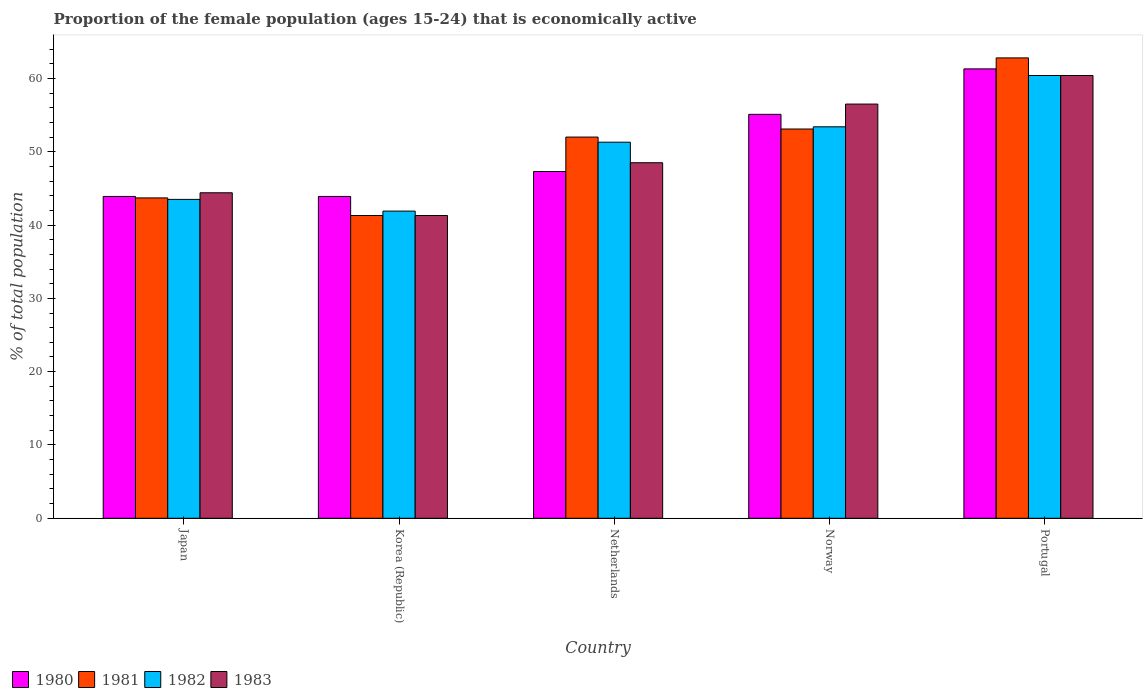How many different coloured bars are there?
Give a very brief answer. 4. How many groups of bars are there?
Give a very brief answer. 5. Are the number of bars on each tick of the X-axis equal?
Keep it short and to the point. Yes. How many bars are there on the 1st tick from the left?
Your response must be concise. 4. How many bars are there on the 4th tick from the right?
Your answer should be compact. 4. What is the label of the 1st group of bars from the left?
Keep it short and to the point. Japan. What is the proportion of the female population that is economically active in 1981 in Norway?
Ensure brevity in your answer.  53.1. Across all countries, what is the maximum proportion of the female population that is economically active in 1981?
Make the answer very short. 62.8. Across all countries, what is the minimum proportion of the female population that is economically active in 1981?
Provide a succinct answer. 41.3. In which country was the proportion of the female population that is economically active in 1980 maximum?
Provide a succinct answer. Portugal. What is the total proportion of the female population that is economically active in 1980 in the graph?
Provide a succinct answer. 251.5. What is the difference between the proportion of the female population that is economically active in 1980 in Japan and that in Norway?
Offer a very short reply. -11.2. What is the difference between the proportion of the female population that is economically active in 1980 in Portugal and the proportion of the female population that is economically active in 1981 in Netherlands?
Give a very brief answer. 9.3. What is the average proportion of the female population that is economically active in 1980 per country?
Give a very brief answer. 50.3. What is the difference between the proportion of the female population that is economically active of/in 1981 and proportion of the female population that is economically active of/in 1980 in Japan?
Offer a very short reply. -0.2. In how many countries, is the proportion of the female population that is economically active in 1981 greater than 42 %?
Your answer should be compact. 4. What is the ratio of the proportion of the female population that is economically active in 1980 in Japan to that in Norway?
Offer a terse response. 0.8. What is the difference between the highest and the lowest proportion of the female population that is economically active in 1983?
Make the answer very short. 19.1. In how many countries, is the proportion of the female population that is economically active in 1980 greater than the average proportion of the female population that is economically active in 1980 taken over all countries?
Offer a very short reply. 2. Is the sum of the proportion of the female population that is economically active in 1981 in Japan and Netherlands greater than the maximum proportion of the female population that is economically active in 1983 across all countries?
Offer a terse response. Yes. Is it the case that in every country, the sum of the proportion of the female population that is economically active in 1980 and proportion of the female population that is economically active in 1983 is greater than the sum of proportion of the female population that is economically active in 1982 and proportion of the female population that is economically active in 1981?
Provide a succinct answer. No. How many countries are there in the graph?
Ensure brevity in your answer.  5. What is the difference between two consecutive major ticks on the Y-axis?
Ensure brevity in your answer.  10. Where does the legend appear in the graph?
Provide a short and direct response. Bottom left. How many legend labels are there?
Ensure brevity in your answer.  4. How are the legend labels stacked?
Keep it short and to the point. Horizontal. What is the title of the graph?
Provide a short and direct response. Proportion of the female population (ages 15-24) that is economically active. What is the label or title of the X-axis?
Keep it short and to the point. Country. What is the label or title of the Y-axis?
Make the answer very short. % of total population. What is the % of total population of 1980 in Japan?
Provide a short and direct response. 43.9. What is the % of total population of 1981 in Japan?
Your response must be concise. 43.7. What is the % of total population of 1982 in Japan?
Your response must be concise. 43.5. What is the % of total population of 1983 in Japan?
Your answer should be compact. 44.4. What is the % of total population in 1980 in Korea (Republic)?
Your response must be concise. 43.9. What is the % of total population of 1981 in Korea (Republic)?
Your answer should be very brief. 41.3. What is the % of total population in 1982 in Korea (Republic)?
Ensure brevity in your answer.  41.9. What is the % of total population of 1983 in Korea (Republic)?
Your response must be concise. 41.3. What is the % of total population of 1980 in Netherlands?
Offer a terse response. 47.3. What is the % of total population of 1982 in Netherlands?
Your response must be concise. 51.3. What is the % of total population in 1983 in Netherlands?
Your response must be concise. 48.5. What is the % of total population of 1980 in Norway?
Make the answer very short. 55.1. What is the % of total population in 1981 in Norway?
Your answer should be compact. 53.1. What is the % of total population in 1982 in Norway?
Ensure brevity in your answer.  53.4. What is the % of total population of 1983 in Norway?
Keep it short and to the point. 56.5. What is the % of total population of 1980 in Portugal?
Offer a very short reply. 61.3. What is the % of total population of 1981 in Portugal?
Make the answer very short. 62.8. What is the % of total population in 1982 in Portugal?
Provide a succinct answer. 60.4. What is the % of total population in 1983 in Portugal?
Offer a very short reply. 60.4. Across all countries, what is the maximum % of total population of 1980?
Your answer should be very brief. 61.3. Across all countries, what is the maximum % of total population in 1981?
Give a very brief answer. 62.8. Across all countries, what is the maximum % of total population of 1982?
Give a very brief answer. 60.4. Across all countries, what is the maximum % of total population in 1983?
Give a very brief answer. 60.4. Across all countries, what is the minimum % of total population of 1980?
Provide a succinct answer. 43.9. Across all countries, what is the minimum % of total population in 1981?
Provide a succinct answer. 41.3. Across all countries, what is the minimum % of total population in 1982?
Your response must be concise. 41.9. Across all countries, what is the minimum % of total population in 1983?
Offer a terse response. 41.3. What is the total % of total population of 1980 in the graph?
Your answer should be compact. 251.5. What is the total % of total population of 1981 in the graph?
Keep it short and to the point. 252.9. What is the total % of total population of 1982 in the graph?
Provide a succinct answer. 250.5. What is the total % of total population of 1983 in the graph?
Your response must be concise. 251.1. What is the difference between the % of total population of 1981 in Japan and that in Korea (Republic)?
Ensure brevity in your answer.  2.4. What is the difference between the % of total population in 1983 in Japan and that in Korea (Republic)?
Make the answer very short. 3.1. What is the difference between the % of total population in 1982 in Japan and that in Netherlands?
Provide a short and direct response. -7.8. What is the difference between the % of total population of 1983 in Japan and that in Netherlands?
Your response must be concise. -4.1. What is the difference between the % of total population of 1980 in Japan and that in Norway?
Offer a very short reply. -11.2. What is the difference between the % of total population in 1980 in Japan and that in Portugal?
Keep it short and to the point. -17.4. What is the difference between the % of total population of 1981 in Japan and that in Portugal?
Your response must be concise. -19.1. What is the difference between the % of total population of 1982 in Japan and that in Portugal?
Offer a very short reply. -16.9. What is the difference between the % of total population in 1981 in Korea (Republic) and that in Netherlands?
Ensure brevity in your answer.  -10.7. What is the difference between the % of total population in 1982 in Korea (Republic) and that in Netherlands?
Give a very brief answer. -9.4. What is the difference between the % of total population in 1982 in Korea (Republic) and that in Norway?
Make the answer very short. -11.5. What is the difference between the % of total population of 1983 in Korea (Republic) and that in Norway?
Offer a terse response. -15.2. What is the difference between the % of total population of 1980 in Korea (Republic) and that in Portugal?
Your answer should be very brief. -17.4. What is the difference between the % of total population of 1981 in Korea (Republic) and that in Portugal?
Provide a succinct answer. -21.5. What is the difference between the % of total population of 1982 in Korea (Republic) and that in Portugal?
Ensure brevity in your answer.  -18.5. What is the difference between the % of total population in 1983 in Korea (Republic) and that in Portugal?
Your answer should be very brief. -19.1. What is the difference between the % of total population in 1980 in Netherlands and that in Norway?
Ensure brevity in your answer.  -7.8. What is the difference between the % of total population of 1981 in Netherlands and that in Norway?
Provide a succinct answer. -1.1. What is the difference between the % of total population in 1982 in Netherlands and that in Norway?
Offer a terse response. -2.1. What is the difference between the % of total population in 1981 in Netherlands and that in Portugal?
Offer a very short reply. -10.8. What is the difference between the % of total population of 1983 in Netherlands and that in Portugal?
Offer a terse response. -11.9. What is the difference between the % of total population of 1980 in Norway and that in Portugal?
Your response must be concise. -6.2. What is the difference between the % of total population of 1981 in Norway and that in Portugal?
Offer a terse response. -9.7. What is the difference between the % of total population in 1982 in Norway and that in Portugal?
Give a very brief answer. -7. What is the difference between the % of total population of 1980 in Japan and the % of total population of 1981 in Korea (Republic)?
Provide a short and direct response. 2.6. What is the difference between the % of total population in 1980 in Japan and the % of total population in 1982 in Korea (Republic)?
Ensure brevity in your answer.  2. What is the difference between the % of total population of 1980 in Japan and the % of total population of 1983 in Korea (Republic)?
Your answer should be compact. 2.6. What is the difference between the % of total population of 1981 in Japan and the % of total population of 1982 in Korea (Republic)?
Offer a terse response. 1.8. What is the difference between the % of total population of 1980 in Japan and the % of total population of 1982 in Netherlands?
Give a very brief answer. -7.4. What is the difference between the % of total population of 1980 in Japan and the % of total population of 1983 in Netherlands?
Make the answer very short. -4.6. What is the difference between the % of total population in 1981 in Japan and the % of total population in 1982 in Netherlands?
Offer a very short reply. -7.6. What is the difference between the % of total population in 1982 in Japan and the % of total population in 1983 in Netherlands?
Offer a terse response. -5. What is the difference between the % of total population of 1980 in Japan and the % of total population of 1983 in Norway?
Make the answer very short. -12.6. What is the difference between the % of total population of 1981 in Japan and the % of total population of 1983 in Norway?
Provide a short and direct response. -12.8. What is the difference between the % of total population of 1982 in Japan and the % of total population of 1983 in Norway?
Make the answer very short. -13. What is the difference between the % of total population in 1980 in Japan and the % of total population in 1981 in Portugal?
Your response must be concise. -18.9. What is the difference between the % of total population in 1980 in Japan and the % of total population in 1982 in Portugal?
Your answer should be very brief. -16.5. What is the difference between the % of total population of 1980 in Japan and the % of total population of 1983 in Portugal?
Your response must be concise. -16.5. What is the difference between the % of total population of 1981 in Japan and the % of total population of 1982 in Portugal?
Your answer should be very brief. -16.7. What is the difference between the % of total population of 1981 in Japan and the % of total population of 1983 in Portugal?
Provide a succinct answer. -16.7. What is the difference between the % of total population of 1982 in Japan and the % of total population of 1983 in Portugal?
Your answer should be very brief. -16.9. What is the difference between the % of total population of 1980 in Korea (Republic) and the % of total population of 1981 in Netherlands?
Your response must be concise. -8.1. What is the difference between the % of total population of 1981 in Korea (Republic) and the % of total population of 1982 in Netherlands?
Provide a short and direct response. -10. What is the difference between the % of total population in 1982 in Korea (Republic) and the % of total population in 1983 in Netherlands?
Keep it short and to the point. -6.6. What is the difference between the % of total population in 1980 in Korea (Republic) and the % of total population in 1981 in Norway?
Provide a succinct answer. -9.2. What is the difference between the % of total population of 1981 in Korea (Republic) and the % of total population of 1982 in Norway?
Offer a terse response. -12.1. What is the difference between the % of total population in 1981 in Korea (Republic) and the % of total population in 1983 in Norway?
Provide a succinct answer. -15.2. What is the difference between the % of total population in 1982 in Korea (Republic) and the % of total population in 1983 in Norway?
Provide a succinct answer. -14.6. What is the difference between the % of total population of 1980 in Korea (Republic) and the % of total population of 1981 in Portugal?
Keep it short and to the point. -18.9. What is the difference between the % of total population in 1980 in Korea (Republic) and the % of total population in 1982 in Portugal?
Offer a terse response. -16.5. What is the difference between the % of total population in 1980 in Korea (Republic) and the % of total population in 1983 in Portugal?
Offer a very short reply. -16.5. What is the difference between the % of total population of 1981 in Korea (Republic) and the % of total population of 1982 in Portugal?
Offer a very short reply. -19.1. What is the difference between the % of total population of 1981 in Korea (Republic) and the % of total population of 1983 in Portugal?
Provide a succinct answer. -19.1. What is the difference between the % of total population of 1982 in Korea (Republic) and the % of total population of 1983 in Portugal?
Make the answer very short. -18.5. What is the difference between the % of total population in 1980 in Netherlands and the % of total population in 1983 in Norway?
Make the answer very short. -9.2. What is the difference between the % of total population of 1980 in Netherlands and the % of total population of 1981 in Portugal?
Give a very brief answer. -15.5. What is the difference between the % of total population of 1980 in Netherlands and the % of total population of 1982 in Portugal?
Your answer should be very brief. -13.1. What is the difference between the % of total population in 1981 in Netherlands and the % of total population in 1982 in Portugal?
Your response must be concise. -8.4. What is the difference between the % of total population in 1982 in Netherlands and the % of total population in 1983 in Portugal?
Ensure brevity in your answer.  -9.1. What is the difference between the % of total population of 1980 in Norway and the % of total population of 1982 in Portugal?
Your answer should be very brief. -5.3. What is the difference between the % of total population of 1980 in Norway and the % of total population of 1983 in Portugal?
Your answer should be compact. -5.3. What is the difference between the % of total population of 1981 in Norway and the % of total population of 1982 in Portugal?
Offer a terse response. -7.3. What is the difference between the % of total population of 1981 in Norway and the % of total population of 1983 in Portugal?
Your answer should be very brief. -7.3. What is the difference between the % of total population of 1982 in Norway and the % of total population of 1983 in Portugal?
Provide a short and direct response. -7. What is the average % of total population in 1980 per country?
Offer a very short reply. 50.3. What is the average % of total population in 1981 per country?
Your answer should be very brief. 50.58. What is the average % of total population of 1982 per country?
Ensure brevity in your answer.  50.1. What is the average % of total population of 1983 per country?
Ensure brevity in your answer.  50.22. What is the difference between the % of total population in 1980 and % of total population in 1981 in Japan?
Offer a terse response. 0.2. What is the difference between the % of total population in 1980 and % of total population in 1982 in Japan?
Offer a terse response. 0.4. What is the difference between the % of total population in 1980 and % of total population in 1981 in Korea (Republic)?
Ensure brevity in your answer.  2.6. What is the difference between the % of total population in 1981 and % of total population in 1982 in Korea (Republic)?
Your answer should be compact. -0.6. What is the difference between the % of total population in 1981 and % of total population in 1983 in Korea (Republic)?
Make the answer very short. 0. What is the difference between the % of total population of 1982 and % of total population of 1983 in Korea (Republic)?
Provide a short and direct response. 0.6. What is the difference between the % of total population in 1980 and % of total population in 1982 in Netherlands?
Ensure brevity in your answer.  -4. What is the difference between the % of total population of 1980 and % of total population of 1983 in Netherlands?
Offer a terse response. -1.2. What is the difference between the % of total population of 1982 and % of total population of 1983 in Netherlands?
Your answer should be very brief. 2.8. What is the difference between the % of total population of 1980 and % of total population of 1981 in Norway?
Keep it short and to the point. 2. What is the difference between the % of total population in 1982 and % of total population in 1983 in Norway?
Offer a terse response. -3.1. What is the difference between the % of total population of 1980 and % of total population of 1981 in Portugal?
Make the answer very short. -1.5. What is the ratio of the % of total population of 1980 in Japan to that in Korea (Republic)?
Your answer should be compact. 1. What is the ratio of the % of total population of 1981 in Japan to that in Korea (Republic)?
Offer a terse response. 1.06. What is the ratio of the % of total population of 1982 in Japan to that in Korea (Republic)?
Your answer should be compact. 1.04. What is the ratio of the % of total population of 1983 in Japan to that in Korea (Republic)?
Make the answer very short. 1.08. What is the ratio of the % of total population of 1980 in Japan to that in Netherlands?
Provide a short and direct response. 0.93. What is the ratio of the % of total population in 1981 in Japan to that in Netherlands?
Make the answer very short. 0.84. What is the ratio of the % of total population of 1982 in Japan to that in Netherlands?
Your answer should be very brief. 0.85. What is the ratio of the % of total population in 1983 in Japan to that in Netherlands?
Offer a terse response. 0.92. What is the ratio of the % of total population of 1980 in Japan to that in Norway?
Offer a very short reply. 0.8. What is the ratio of the % of total population of 1981 in Japan to that in Norway?
Your response must be concise. 0.82. What is the ratio of the % of total population in 1982 in Japan to that in Norway?
Offer a very short reply. 0.81. What is the ratio of the % of total population of 1983 in Japan to that in Norway?
Make the answer very short. 0.79. What is the ratio of the % of total population in 1980 in Japan to that in Portugal?
Your answer should be very brief. 0.72. What is the ratio of the % of total population in 1981 in Japan to that in Portugal?
Give a very brief answer. 0.7. What is the ratio of the % of total population in 1982 in Japan to that in Portugal?
Ensure brevity in your answer.  0.72. What is the ratio of the % of total population of 1983 in Japan to that in Portugal?
Ensure brevity in your answer.  0.74. What is the ratio of the % of total population in 1980 in Korea (Republic) to that in Netherlands?
Offer a terse response. 0.93. What is the ratio of the % of total population in 1981 in Korea (Republic) to that in Netherlands?
Give a very brief answer. 0.79. What is the ratio of the % of total population of 1982 in Korea (Republic) to that in Netherlands?
Offer a terse response. 0.82. What is the ratio of the % of total population in 1983 in Korea (Republic) to that in Netherlands?
Your answer should be very brief. 0.85. What is the ratio of the % of total population of 1980 in Korea (Republic) to that in Norway?
Offer a terse response. 0.8. What is the ratio of the % of total population of 1981 in Korea (Republic) to that in Norway?
Provide a short and direct response. 0.78. What is the ratio of the % of total population in 1982 in Korea (Republic) to that in Norway?
Provide a short and direct response. 0.78. What is the ratio of the % of total population of 1983 in Korea (Republic) to that in Norway?
Make the answer very short. 0.73. What is the ratio of the % of total population of 1980 in Korea (Republic) to that in Portugal?
Keep it short and to the point. 0.72. What is the ratio of the % of total population in 1981 in Korea (Republic) to that in Portugal?
Ensure brevity in your answer.  0.66. What is the ratio of the % of total population in 1982 in Korea (Republic) to that in Portugal?
Offer a very short reply. 0.69. What is the ratio of the % of total population in 1983 in Korea (Republic) to that in Portugal?
Make the answer very short. 0.68. What is the ratio of the % of total population in 1980 in Netherlands to that in Norway?
Give a very brief answer. 0.86. What is the ratio of the % of total population in 1981 in Netherlands to that in Norway?
Your answer should be very brief. 0.98. What is the ratio of the % of total population in 1982 in Netherlands to that in Norway?
Provide a short and direct response. 0.96. What is the ratio of the % of total population in 1983 in Netherlands to that in Norway?
Ensure brevity in your answer.  0.86. What is the ratio of the % of total population in 1980 in Netherlands to that in Portugal?
Your answer should be compact. 0.77. What is the ratio of the % of total population in 1981 in Netherlands to that in Portugal?
Offer a terse response. 0.83. What is the ratio of the % of total population in 1982 in Netherlands to that in Portugal?
Ensure brevity in your answer.  0.85. What is the ratio of the % of total population of 1983 in Netherlands to that in Portugal?
Provide a short and direct response. 0.8. What is the ratio of the % of total population in 1980 in Norway to that in Portugal?
Offer a terse response. 0.9. What is the ratio of the % of total population in 1981 in Norway to that in Portugal?
Your answer should be compact. 0.85. What is the ratio of the % of total population of 1982 in Norway to that in Portugal?
Provide a short and direct response. 0.88. What is the ratio of the % of total population of 1983 in Norway to that in Portugal?
Offer a very short reply. 0.94. What is the difference between the highest and the second highest % of total population of 1982?
Ensure brevity in your answer.  7. What is the difference between the highest and the second highest % of total population in 1983?
Offer a very short reply. 3.9. What is the difference between the highest and the lowest % of total population in 1980?
Offer a terse response. 17.4. What is the difference between the highest and the lowest % of total population in 1981?
Your answer should be very brief. 21.5. What is the difference between the highest and the lowest % of total population in 1982?
Your answer should be compact. 18.5. 